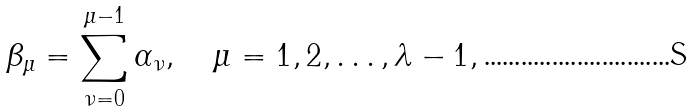Convert formula to latex. <formula><loc_0><loc_0><loc_500><loc_500>\beta _ { \mu } = \sum _ { \nu = 0 } ^ { \mu - 1 } \alpha _ { \nu } , \quad \mu = 1 , 2 , \dots , \lambda - 1 ,</formula> 